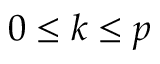Convert formula to latex. <formula><loc_0><loc_0><loc_500><loc_500>0 \leq k \leq p</formula> 